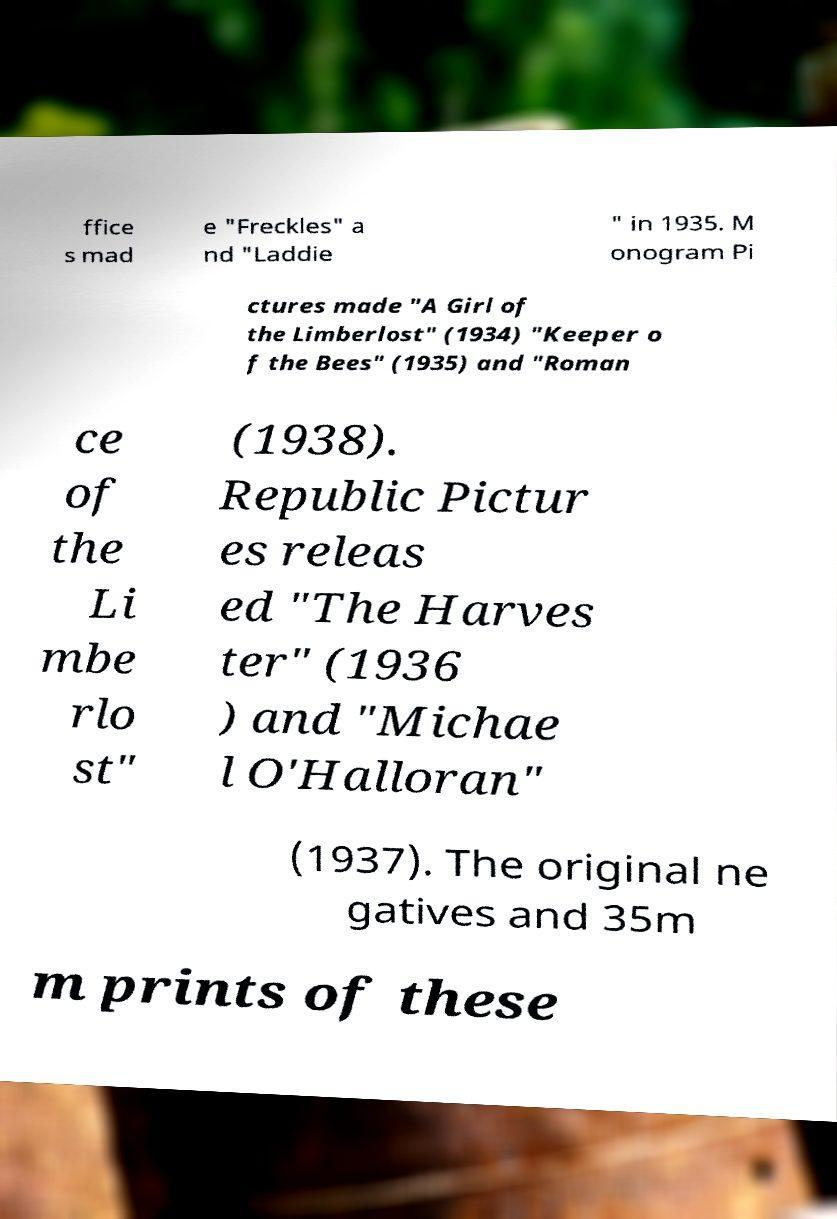Could you assist in decoding the text presented in this image and type it out clearly? ffice s mad e "Freckles" a nd "Laddie " in 1935. M onogram Pi ctures made "A Girl of the Limberlost" (1934) "Keeper o f the Bees" (1935) and "Roman ce of the Li mbe rlo st" (1938). Republic Pictur es releas ed "The Harves ter" (1936 ) and "Michae l O'Halloran" (1937). The original ne gatives and 35m m prints of these 